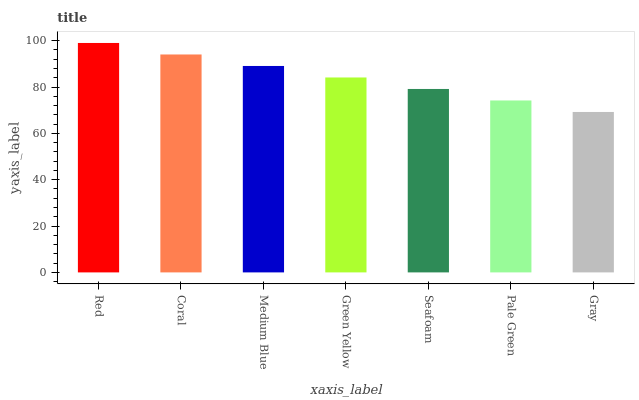Is Gray the minimum?
Answer yes or no. Yes. Is Red the maximum?
Answer yes or no. Yes. Is Coral the minimum?
Answer yes or no. No. Is Coral the maximum?
Answer yes or no. No. Is Red greater than Coral?
Answer yes or no. Yes. Is Coral less than Red?
Answer yes or no. Yes. Is Coral greater than Red?
Answer yes or no. No. Is Red less than Coral?
Answer yes or no. No. Is Green Yellow the high median?
Answer yes or no. Yes. Is Green Yellow the low median?
Answer yes or no. Yes. Is Seafoam the high median?
Answer yes or no. No. Is Pale Green the low median?
Answer yes or no. No. 